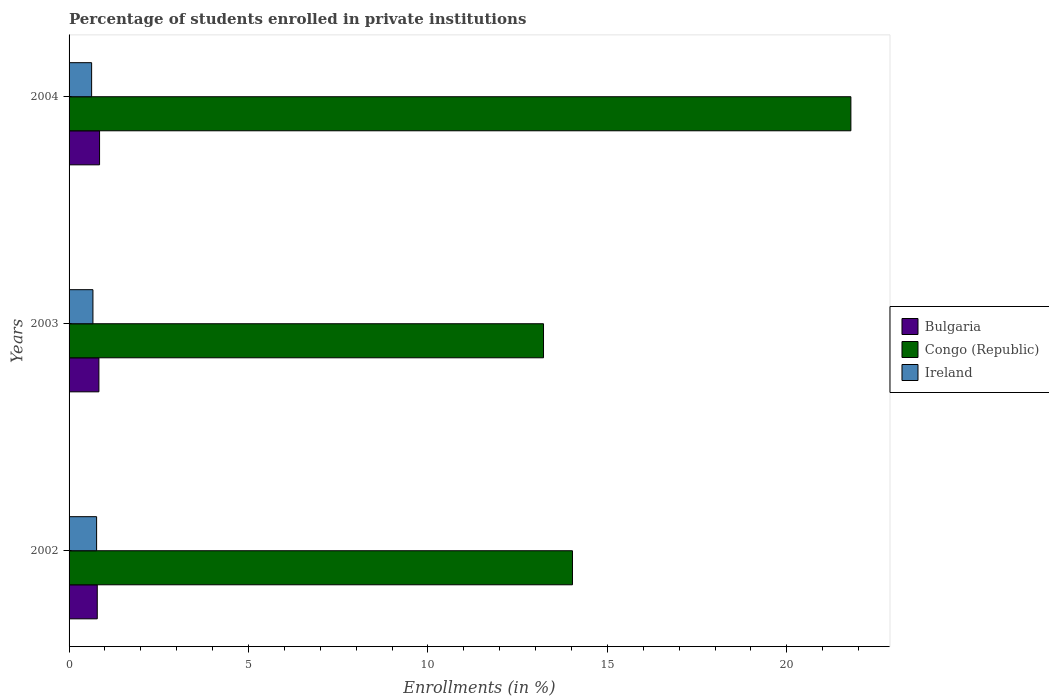How many groups of bars are there?
Your response must be concise. 3. How many bars are there on the 3rd tick from the top?
Ensure brevity in your answer.  3. How many bars are there on the 2nd tick from the bottom?
Offer a very short reply. 3. What is the label of the 2nd group of bars from the top?
Offer a terse response. 2003. What is the percentage of trained teachers in Congo (Republic) in 2003?
Offer a very short reply. 13.22. Across all years, what is the maximum percentage of trained teachers in Congo (Republic)?
Your answer should be very brief. 21.79. Across all years, what is the minimum percentage of trained teachers in Bulgaria?
Make the answer very short. 0.79. What is the total percentage of trained teachers in Ireland in the graph?
Provide a succinct answer. 2.06. What is the difference between the percentage of trained teachers in Ireland in 2002 and that in 2003?
Ensure brevity in your answer.  0.1. What is the difference between the percentage of trained teachers in Ireland in 2004 and the percentage of trained teachers in Bulgaria in 2002?
Provide a short and direct response. -0.16. What is the average percentage of trained teachers in Bulgaria per year?
Ensure brevity in your answer.  0.82. In the year 2004, what is the difference between the percentage of trained teachers in Bulgaria and percentage of trained teachers in Ireland?
Your answer should be compact. 0.22. In how many years, is the percentage of trained teachers in Ireland greater than 4 %?
Your answer should be compact. 0. What is the ratio of the percentage of trained teachers in Bulgaria in 2002 to that in 2004?
Provide a succinct answer. 0.92. What is the difference between the highest and the second highest percentage of trained teachers in Congo (Republic)?
Your answer should be compact. 7.76. What is the difference between the highest and the lowest percentage of trained teachers in Bulgaria?
Keep it short and to the point. 0.06. What does the 2nd bar from the top in 2003 represents?
Offer a terse response. Congo (Republic). What does the 3rd bar from the bottom in 2002 represents?
Your answer should be compact. Ireland. Is it the case that in every year, the sum of the percentage of trained teachers in Ireland and percentage of trained teachers in Bulgaria is greater than the percentage of trained teachers in Congo (Republic)?
Give a very brief answer. No. How many bars are there?
Provide a succinct answer. 9. Are all the bars in the graph horizontal?
Provide a succinct answer. Yes. How many years are there in the graph?
Your response must be concise. 3. What is the difference between two consecutive major ticks on the X-axis?
Make the answer very short. 5. Does the graph contain grids?
Make the answer very short. No. What is the title of the graph?
Provide a short and direct response. Percentage of students enrolled in private institutions. Does "Hong Kong" appear as one of the legend labels in the graph?
Offer a terse response. No. What is the label or title of the X-axis?
Keep it short and to the point. Enrollments (in %). What is the Enrollments (in %) of Bulgaria in 2002?
Provide a short and direct response. 0.79. What is the Enrollments (in %) of Congo (Republic) in 2002?
Give a very brief answer. 14.03. What is the Enrollments (in %) in Ireland in 2002?
Make the answer very short. 0.77. What is the Enrollments (in %) in Bulgaria in 2003?
Keep it short and to the point. 0.83. What is the Enrollments (in %) of Congo (Republic) in 2003?
Provide a succinct answer. 13.22. What is the Enrollments (in %) of Ireland in 2003?
Offer a very short reply. 0.67. What is the Enrollments (in %) in Bulgaria in 2004?
Give a very brief answer. 0.85. What is the Enrollments (in %) of Congo (Republic) in 2004?
Offer a very short reply. 21.79. What is the Enrollments (in %) of Ireland in 2004?
Give a very brief answer. 0.63. Across all years, what is the maximum Enrollments (in %) in Bulgaria?
Your answer should be compact. 0.85. Across all years, what is the maximum Enrollments (in %) of Congo (Republic)?
Offer a very short reply. 21.79. Across all years, what is the maximum Enrollments (in %) in Ireland?
Offer a terse response. 0.77. Across all years, what is the minimum Enrollments (in %) of Bulgaria?
Ensure brevity in your answer.  0.79. Across all years, what is the minimum Enrollments (in %) of Congo (Republic)?
Give a very brief answer. 13.22. Across all years, what is the minimum Enrollments (in %) in Ireland?
Offer a terse response. 0.63. What is the total Enrollments (in %) in Bulgaria in the graph?
Your response must be concise. 2.47. What is the total Enrollments (in %) of Congo (Republic) in the graph?
Make the answer very short. 49.03. What is the total Enrollments (in %) of Ireland in the graph?
Your response must be concise. 2.06. What is the difference between the Enrollments (in %) in Bulgaria in 2002 and that in 2003?
Provide a short and direct response. -0.05. What is the difference between the Enrollments (in %) in Congo (Republic) in 2002 and that in 2003?
Provide a short and direct response. 0.81. What is the difference between the Enrollments (in %) of Ireland in 2002 and that in 2003?
Provide a short and direct response. 0.1. What is the difference between the Enrollments (in %) of Bulgaria in 2002 and that in 2004?
Make the answer very short. -0.06. What is the difference between the Enrollments (in %) of Congo (Republic) in 2002 and that in 2004?
Ensure brevity in your answer.  -7.76. What is the difference between the Enrollments (in %) of Ireland in 2002 and that in 2004?
Provide a short and direct response. 0.14. What is the difference between the Enrollments (in %) of Bulgaria in 2003 and that in 2004?
Provide a succinct answer. -0.02. What is the difference between the Enrollments (in %) of Congo (Republic) in 2003 and that in 2004?
Provide a short and direct response. -8.57. What is the difference between the Enrollments (in %) in Ireland in 2003 and that in 2004?
Ensure brevity in your answer.  0.04. What is the difference between the Enrollments (in %) of Bulgaria in 2002 and the Enrollments (in %) of Congo (Republic) in 2003?
Your answer should be very brief. -12.44. What is the difference between the Enrollments (in %) of Bulgaria in 2002 and the Enrollments (in %) of Ireland in 2003?
Your response must be concise. 0.12. What is the difference between the Enrollments (in %) of Congo (Republic) in 2002 and the Enrollments (in %) of Ireland in 2003?
Provide a short and direct response. 13.36. What is the difference between the Enrollments (in %) of Bulgaria in 2002 and the Enrollments (in %) of Congo (Republic) in 2004?
Ensure brevity in your answer.  -21. What is the difference between the Enrollments (in %) of Bulgaria in 2002 and the Enrollments (in %) of Ireland in 2004?
Make the answer very short. 0.16. What is the difference between the Enrollments (in %) of Congo (Republic) in 2002 and the Enrollments (in %) of Ireland in 2004?
Your answer should be very brief. 13.4. What is the difference between the Enrollments (in %) of Bulgaria in 2003 and the Enrollments (in %) of Congo (Republic) in 2004?
Make the answer very short. -20.95. What is the difference between the Enrollments (in %) in Bulgaria in 2003 and the Enrollments (in %) in Ireland in 2004?
Offer a terse response. 0.2. What is the difference between the Enrollments (in %) in Congo (Republic) in 2003 and the Enrollments (in %) in Ireland in 2004?
Provide a succinct answer. 12.59. What is the average Enrollments (in %) of Bulgaria per year?
Offer a terse response. 0.82. What is the average Enrollments (in %) of Congo (Republic) per year?
Provide a short and direct response. 16.34. What is the average Enrollments (in %) of Ireland per year?
Provide a short and direct response. 0.69. In the year 2002, what is the difference between the Enrollments (in %) of Bulgaria and Enrollments (in %) of Congo (Republic)?
Your answer should be very brief. -13.24. In the year 2002, what is the difference between the Enrollments (in %) of Bulgaria and Enrollments (in %) of Ireland?
Your answer should be compact. 0.02. In the year 2002, what is the difference between the Enrollments (in %) of Congo (Republic) and Enrollments (in %) of Ireland?
Your answer should be compact. 13.26. In the year 2003, what is the difference between the Enrollments (in %) of Bulgaria and Enrollments (in %) of Congo (Republic)?
Offer a terse response. -12.39. In the year 2003, what is the difference between the Enrollments (in %) of Bulgaria and Enrollments (in %) of Ireland?
Provide a succinct answer. 0.17. In the year 2003, what is the difference between the Enrollments (in %) of Congo (Republic) and Enrollments (in %) of Ireland?
Keep it short and to the point. 12.56. In the year 2004, what is the difference between the Enrollments (in %) of Bulgaria and Enrollments (in %) of Congo (Republic)?
Keep it short and to the point. -20.94. In the year 2004, what is the difference between the Enrollments (in %) in Bulgaria and Enrollments (in %) in Ireland?
Your answer should be very brief. 0.22. In the year 2004, what is the difference between the Enrollments (in %) of Congo (Republic) and Enrollments (in %) of Ireland?
Make the answer very short. 21.16. What is the ratio of the Enrollments (in %) of Bulgaria in 2002 to that in 2003?
Offer a very short reply. 0.95. What is the ratio of the Enrollments (in %) of Congo (Republic) in 2002 to that in 2003?
Provide a succinct answer. 1.06. What is the ratio of the Enrollments (in %) in Ireland in 2002 to that in 2003?
Your answer should be very brief. 1.15. What is the ratio of the Enrollments (in %) of Bulgaria in 2002 to that in 2004?
Offer a very short reply. 0.92. What is the ratio of the Enrollments (in %) in Congo (Republic) in 2002 to that in 2004?
Keep it short and to the point. 0.64. What is the ratio of the Enrollments (in %) of Ireland in 2002 to that in 2004?
Offer a terse response. 1.22. What is the ratio of the Enrollments (in %) in Bulgaria in 2003 to that in 2004?
Keep it short and to the point. 0.98. What is the ratio of the Enrollments (in %) of Congo (Republic) in 2003 to that in 2004?
Keep it short and to the point. 0.61. What is the ratio of the Enrollments (in %) of Ireland in 2003 to that in 2004?
Keep it short and to the point. 1.06. What is the difference between the highest and the second highest Enrollments (in %) of Bulgaria?
Offer a very short reply. 0.02. What is the difference between the highest and the second highest Enrollments (in %) of Congo (Republic)?
Ensure brevity in your answer.  7.76. What is the difference between the highest and the second highest Enrollments (in %) of Ireland?
Offer a very short reply. 0.1. What is the difference between the highest and the lowest Enrollments (in %) of Bulgaria?
Give a very brief answer. 0.06. What is the difference between the highest and the lowest Enrollments (in %) of Congo (Republic)?
Keep it short and to the point. 8.57. What is the difference between the highest and the lowest Enrollments (in %) of Ireland?
Give a very brief answer. 0.14. 